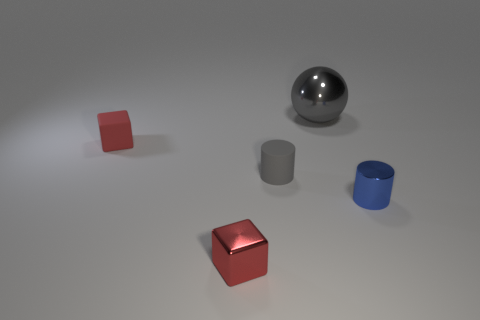Add 2 tiny red metal blocks. How many objects exist? 7 Subtract all blocks. How many objects are left? 3 Add 4 tiny red things. How many tiny red things are left? 6 Add 1 tiny cubes. How many tiny cubes exist? 3 Subtract 1 blue cylinders. How many objects are left? 4 Subtract all red cubes. Subtract all big balls. How many objects are left? 2 